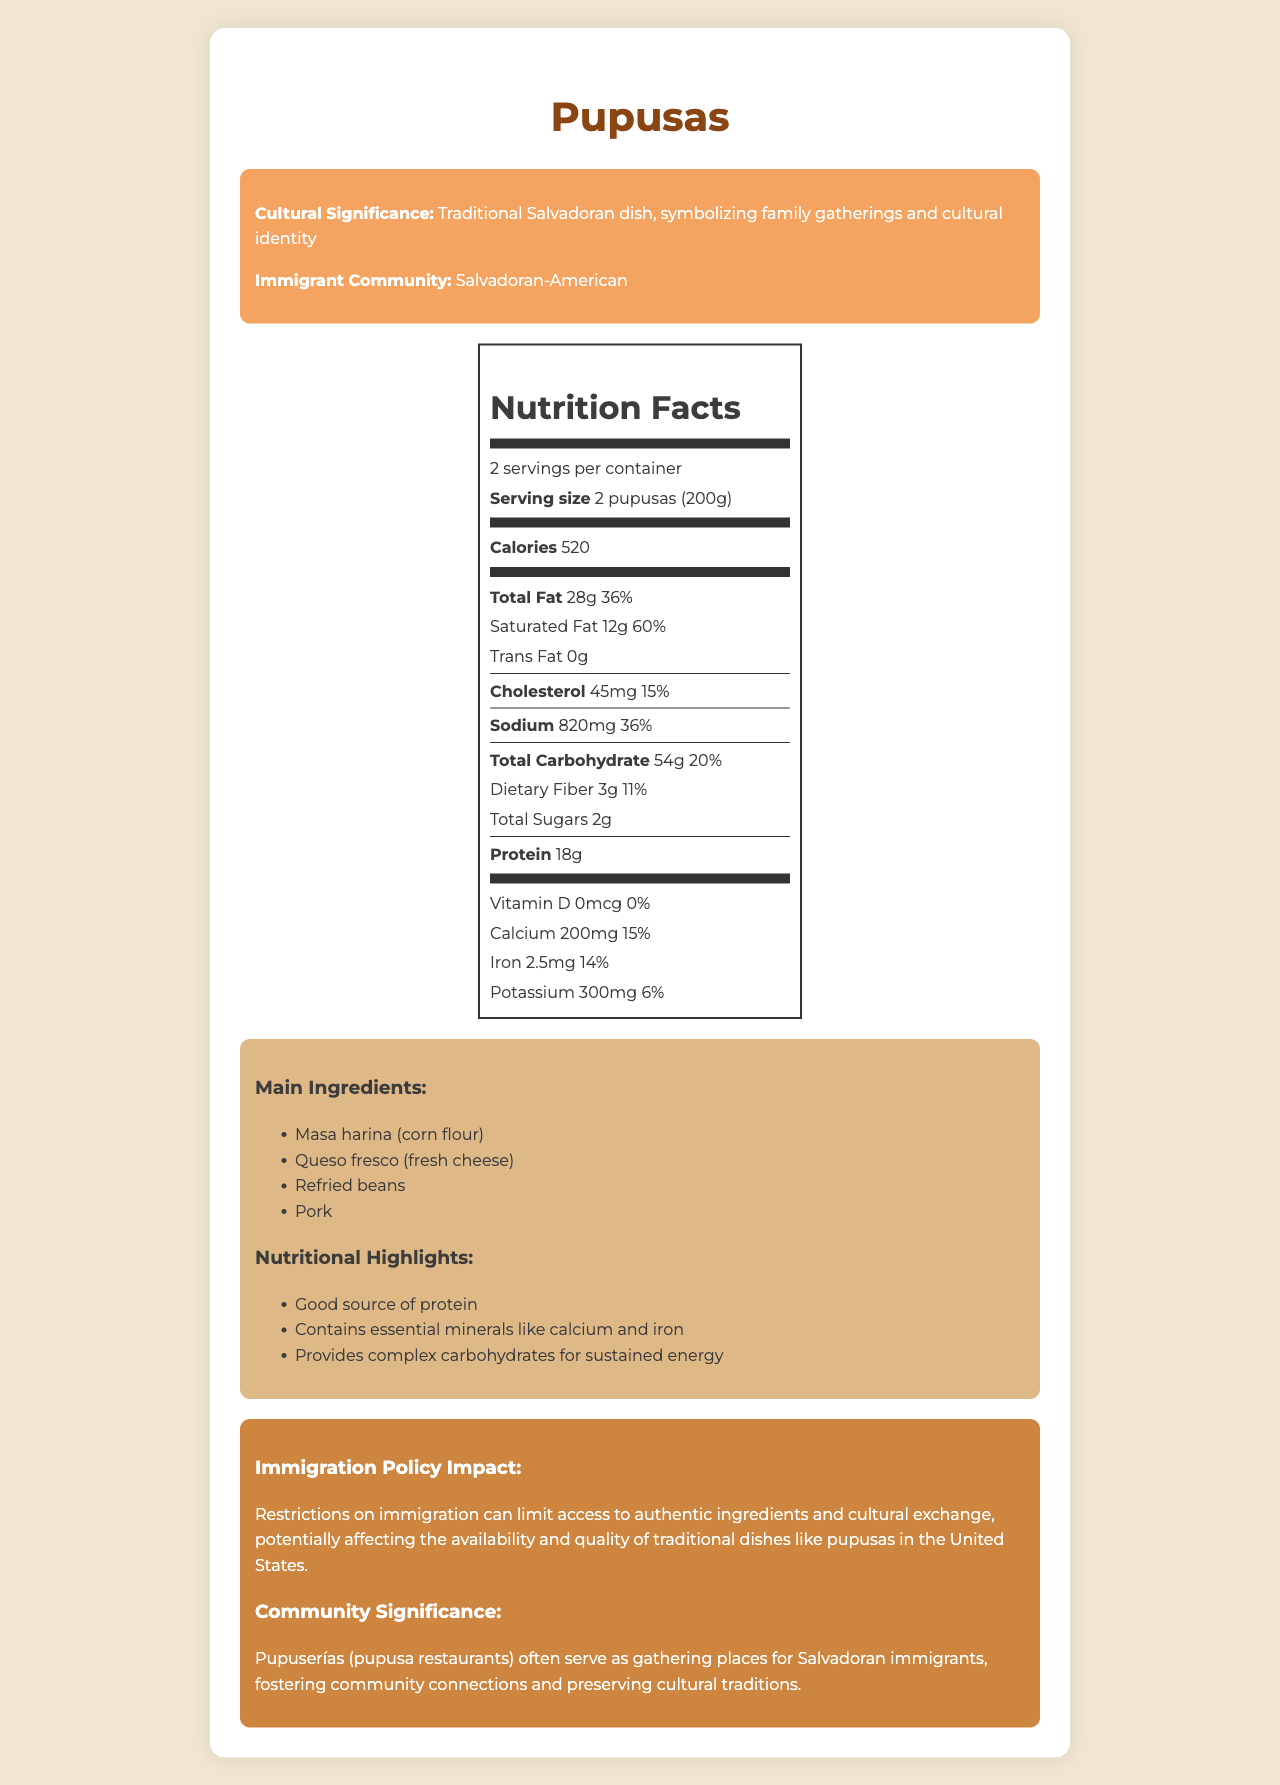what is the serving size for pupusas? The document specifies that the serving size for pupusas is 2 pupusas, equivalent to 200 grams.
Answer: 2 pupusas (200g) how many calories does one serving of pupusas contain? According to the document, one serving of pupusas contains 520 calories.
Answer: 520 calories what percentage of the daily value for total fat does one serving of pupusas provide? The Nutrition Facts label indicates that one serving of pupusas provides 36% of the daily value for total fat.
Answer: 36% what are the main ingredients in pupusas? The document lists these ingredients as the main components of pupusas.
Answer: Masa harina (corn flour), Queso fresco (fresh cheese), Refried beans, Pork what is the cultural significance of pupusas? The cultural significance of pupusas is highlighted as a traditional Salvadoran dish that symbolizes family gatherings and cultural identity.
Answer: Traditional Salvadoran dish, symbolizing family gatherings and cultural identity which nutrient has the highest daily value percentage in one serving of pupusas? A. Sodium B. Protein C. Saturated Fat The Nutrition Facts label shows that saturated fat has the highest daily value percentage at 60%.
Answer: C. Saturated Fat how does immigration policy impact traditional dishes like pupusas? The document explains that restrictive immigration policies can impact the availability of authentic ingredients and cultural exchange, which in turn can affect traditional dishes.
Answer: Restrictions on immigration can limit access to authentic ingredients and cultural exchange, potentially affecting the availability and quality of traditional dishes like pupusas in the United States. is there any vitamin D in pupusas? The Nutrition Facts label states that the amount of vitamin D in pupusas is 0 mcg, which means there is no vitamin D present.
Answer: No based on the document, list one nutritional benefit of pupusas. The document mentions that pupusas are a good source of protein as one of their nutritional highlights.
Answer: Good source of protein how much sodium does one serving of pupusas contain? The Nutrition Facts label indicates that one serving of pupusas contains 820 mg of sodium.
Answer: 820 mg which one of these nutrients is not found in pupusas? A. Trans Fat B. Vitamin D C. Iron D. Calcium The Nutrition Facts label shows 0 g of trans fat in pupusas, thus indicating it is not present.
Answer: A. Trans Fat are pupusas high in total sugars? The document indicates that total sugars in one serving of pupusas amount to 2 grams, which is relatively low.
Answer: No summarize the entire document. The document includes information about the nutrition content, cultural importance, and community role of pupusas, along with commentary on how immigration policies can affect traditional food practices.
Answer: The document provides detailed nutrition facts for pupusas, a traditional Salvadoran dish, including calorie count, fat content, and other nutritional information. It highlights the cultural significance of pupusas within the Salvadoran-American community and discusses the impact of immigration policies on the availability of traditional dishes. Nutritional benefits of pupusas are mentioned, and their role as a community connector is emphasized. how much calcium is found in one serving of pupusas? The Nutrition Facts label specifies that there is 200 mg of calcium in one serving of pupusas.
Answer: 200 mg what is the main idea of the document? The main idea revolves around offering a comprehensive look at the nutritional value, cultural importance, and how immigration policies could affect the traditional dish of pupusas.
Answer: The document provides nutritional information, cultural significance, and the impact of immigration policies on pupusas, a traditional Salvadoran dish. can we determine the exact recipe for pupusas from this document? The document lists the main ingredients but does not provide specific quantities or the method required to prepare them, so the exact recipe cannot be determined.
Answer: Not enough information is there any information about the impact of dietary fiber in pupusas? The Nutrition Facts label states that one serving of pupusas contains 3 grams of dietary fiber, which provides 11% of the daily value.
Answer: Yes 